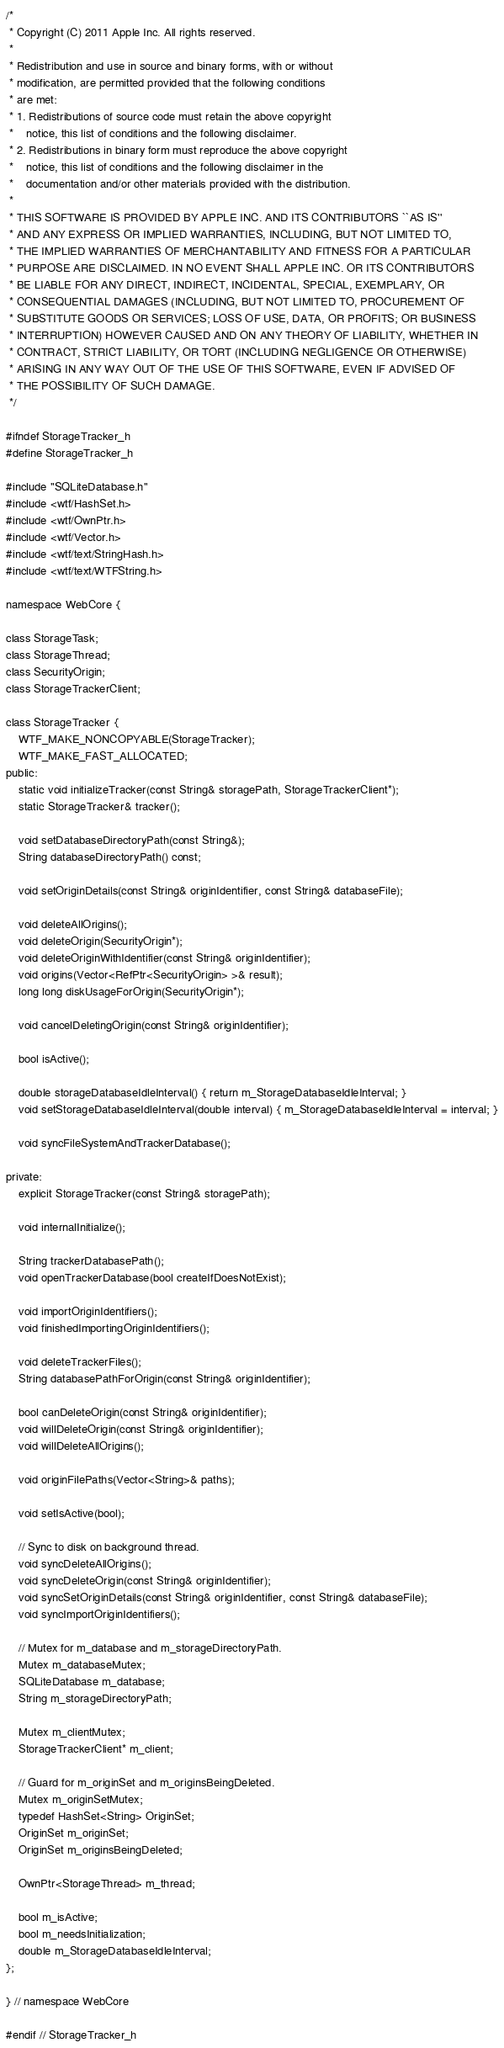<code> <loc_0><loc_0><loc_500><loc_500><_C_>/*
 * Copyright (C) 2011 Apple Inc. All rights reserved.
 *
 * Redistribution and use in source and binary forms, with or without
 * modification, are permitted provided that the following conditions
 * are met:
 * 1. Redistributions of source code must retain the above copyright
 *    notice, this list of conditions and the following disclaimer.
 * 2. Redistributions in binary form must reproduce the above copyright
 *    notice, this list of conditions and the following disclaimer in the
 *    documentation and/or other materials provided with the distribution.
 *
 * THIS SOFTWARE IS PROVIDED BY APPLE INC. AND ITS CONTRIBUTORS ``AS IS''
 * AND ANY EXPRESS OR IMPLIED WARRANTIES, INCLUDING, BUT NOT LIMITED TO,
 * THE IMPLIED WARRANTIES OF MERCHANTABILITY AND FITNESS FOR A PARTICULAR
 * PURPOSE ARE DISCLAIMED. IN NO EVENT SHALL APPLE INC. OR ITS CONTRIBUTORS
 * BE LIABLE FOR ANY DIRECT, INDIRECT, INCIDENTAL, SPECIAL, EXEMPLARY, OR
 * CONSEQUENTIAL DAMAGES (INCLUDING, BUT NOT LIMITED TO, PROCUREMENT OF
 * SUBSTITUTE GOODS OR SERVICES; LOSS OF USE, DATA, OR PROFITS; OR BUSINESS
 * INTERRUPTION) HOWEVER CAUSED AND ON ANY THEORY OF LIABILITY, WHETHER IN
 * CONTRACT, STRICT LIABILITY, OR TORT (INCLUDING NEGLIGENCE OR OTHERWISE)
 * ARISING IN ANY WAY OUT OF THE USE OF THIS SOFTWARE, EVEN IF ADVISED OF
 * THE POSSIBILITY OF SUCH DAMAGE.
 */

#ifndef StorageTracker_h
#define StorageTracker_h

#include "SQLiteDatabase.h"
#include <wtf/HashSet.h>
#include <wtf/OwnPtr.h>
#include <wtf/Vector.h>
#include <wtf/text/StringHash.h>
#include <wtf/text/WTFString.h>

namespace WebCore {

class StorageTask;
class StorageThread;
class SecurityOrigin;
class StorageTrackerClient;    

class StorageTracker {
    WTF_MAKE_NONCOPYABLE(StorageTracker);
    WTF_MAKE_FAST_ALLOCATED;
public:
    static void initializeTracker(const String& storagePath, StorageTrackerClient*);
    static StorageTracker& tracker();

    void setDatabaseDirectoryPath(const String&);
    String databaseDirectoryPath() const;

    void setOriginDetails(const String& originIdentifier, const String& databaseFile);
    
    void deleteAllOrigins();
    void deleteOrigin(SecurityOrigin*);
    void deleteOriginWithIdentifier(const String& originIdentifier);
    void origins(Vector<RefPtr<SecurityOrigin> >& result);
    long long diskUsageForOrigin(SecurityOrigin*);
    
    void cancelDeletingOrigin(const String& originIdentifier);
    
    bool isActive();

    double storageDatabaseIdleInterval() { return m_StorageDatabaseIdleInterval; }
    void setStorageDatabaseIdleInterval(double interval) { m_StorageDatabaseIdleInterval = interval; }

    void syncFileSystemAndTrackerDatabase();

private:
    explicit StorageTracker(const String& storagePath);

    void internalInitialize();

    String trackerDatabasePath();
    void openTrackerDatabase(bool createIfDoesNotExist);

    void importOriginIdentifiers();
    void finishedImportingOriginIdentifiers();
    
    void deleteTrackerFiles();
    String databasePathForOrigin(const String& originIdentifier);

    bool canDeleteOrigin(const String& originIdentifier);
    void willDeleteOrigin(const String& originIdentifier);
    void willDeleteAllOrigins();

    void originFilePaths(Vector<String>& paths);
    
    void setIsActive(bool);

    // Sync to disk on background thread.
    void syncDeleteAllOrigins();
    void syncDeleteOrigin(const String& originIdentifier);
    void syncSetOriginDetails(const String& originIdentifier, const String& databaseFile);
    void syncImportOriginIdentifiers();

    // Mutex for m_database and m_storageDirectoryPath.
    Mutex m_databaseMutex;
    SQLiteDatabase m_database;
    String m_storageDirectoryPath;

    Mutex m_clientMutex;
    StorageTrackerClient* m_client;

    // Guard for m_originSet and m_originsBeingDeleted.
    Mutex m_originSetMutex;
    typedef HashSet<String> OriginSet;
    OriginSet m_originSet;
    OriginSet m_originsBeingDeleted;

    OwnPtr<StorageThread> m_thread;
    
    bool m_isActive;
    bool m_needsInitialization;
    double m_StorageDatabaseIdleInterval;
};
    
} // namespace WebCore

#endif // StorageTracker_h
</code> 